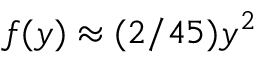Convert formula to latex. <formula><loc_0><loc_0><loc_500><loc_500>f ( y ) \approx ( 2 / 4 5 ) y ^ { 2 }</formula> 